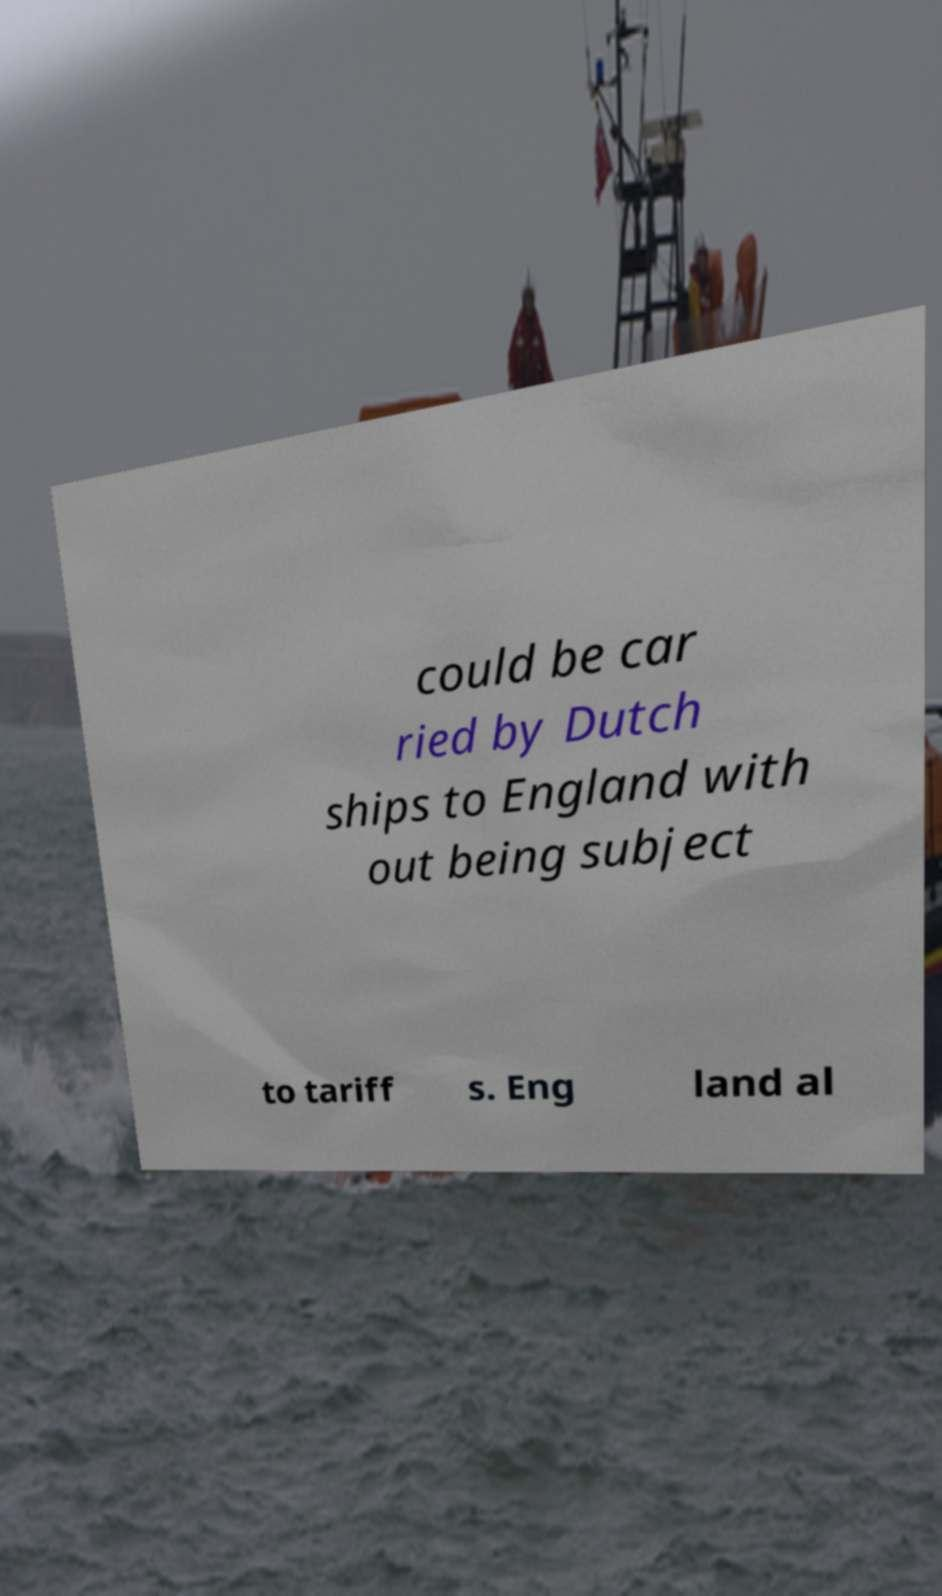Please identify and transcribe the text found in this image. could be car ried by Dutch ships to England with out being subject to tariff s. Eng land al 